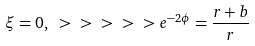<formula> <loc_0><loc_0><loc_500><loc_500>\xi = 0 , \ > \ > \ > \ > \ > e ^ { - 2 \phi } = \frac { r + b } { r }</formula> 